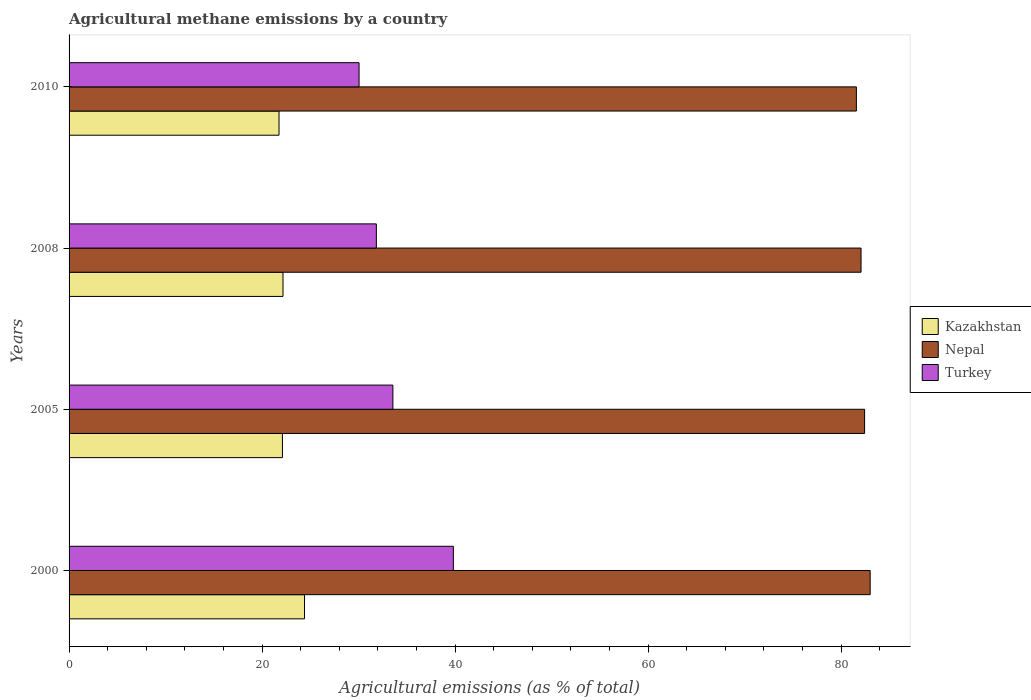How many different coloured bars are there?
Give a very brief answer. 3. How many groups of bars are there?
Provide a succinct answer. 4. Are the number of bars per tick equal to the number of legend labels?
Offer a very short reply. Yes. Are the number of bars on each tick of the Y-axis equal?
Keep it short and to the point. Yes. How many bars are there on the 1st tick from the top?
Keep it short and to the point. 3. How many bars are there on the 1st tick from the bottom?
Make the answer very short. 3. What is the label of the 2nd group of bars from the top?
Offer a very short reply. 2008. What is the amount of agricultural methane emitted in Turkey in 2010?
Provide a short and direct response. 30.05. Across all years, what is the maximum amount of agricultural methane emitted in Nepal?
Ensure brevity in your answer.  83.02. Across all years, what is the minimum amount of agricultural methane emitted in Turkey?
Your response must be concise. 30.05. In which year was the amount of agricultural methane emitted in Turkey maximum?
Ensure brevity in your answer.  2000. In which year was the amount of agricultural methane emitted in Turkey minimum?
Offer a terse response. 2010. What is the total amount of agricultural methane emitted in Turkey in the graph?
Keep it short and to the point. 135.29. What is the difference between the amount of agricultural methane emitted in Nepal in 2008 and that in 2010?
Give a very brief answer. 0.48. What is the difference between the amount of agricultural methane emitted in Turkey in 2005 and the amount of agricultural methane emitted in Kazakhstan in 2008?
Your answer should be compact. 11.39. What is the average amount of agricultural methane emitted in Turkey per year?
Offer a terse response. 33.82. In the year 2010, what is the difference between the amount of agricultural methane emitted in Turkey and amount of agricultural methane emitted in Nepal?
Provide a succinct answer. -51.54. What is the ratio of the amount of agricultural methane emitted in Kazakhstan in 2000 to that in 2010?
Provide a short and direct response. 1.12. Is the difference between the amount of agricultural methane emitted in Turkey in 2000 and 2005 greater than the difference between the amount of agricultural methane emitted in Nepal in 2000 and 2005?
Offer a terse response. Yes. What is the difference between the highest and the second highest amount of agricultural methane emitted in Nepal?
Your answer should be compact. 0.58. What is the difference between the highest and the lowest amount of agricultural methane emitted in Nepal?
Provide a short and direct response. 1.43. In how many years, is the amount of agricultural methane emitted in Nepal greater than the average amount of agricultural methane emitted in Nepal taken over all years?
Keep it short and to the point. 2. Is the sum of the amount of agricultural methane emitted in Nepal in 2000 and 2010 greater than the maximum amount of agricultural methane emitted in Turkey across all years?
Your answer should be compact. Yes. What does the 3rd bar from the top in 2005 represents?
Provide a succinct answer. Kazakhstan. How many bars are there?
Offer a very short reply. 12. Are all the bars in the graph horizontal?
Your answer should be very brief. Yes. How many years are there in the graph?
Your answer should be very brief. 4. Does the graph contain grids?
Provide a short and direct response. No. What is the title of the graph?
Your response must be concise. Agricultural methane emissions by a country. What is the label or title of the X-axis?
Your response must be concise. Agricultural emissions (as % of total). What is the label or title of the Y-axis?
Provide a succinct answer. Years. What is the Agricultural emissions (as % of total) in Kazakhstan in 2000?
Your answer should be compact. 24.4. What is the Agricultural emissions (as % of total) in Nepal in 2000?
Provide a short and direct response. 83.02. What is the Agricultural emissions (as % of total) of Turkey in 2000?
Make the answer very short. 39.83. What is the Agricultural emissions (as % of total) of Kazakhstan in 2005?
Provide a short and direct response. 22.11. What is the Agricultural emissions (as % of total) of Nepal in 2005?
Your response must be concise. 82.45. What is the Agricultural emissions (as % of total) of Turkey in 2005?
Provide a succinct answer. 33.56. What is the Agricultural emissions (as % of total) of Kazakhstan in 2008?
Make the answer very short. 22.17. What is the Agricultural emissions (as % of total) in Nepal in 2008?
Make the answer very short. 82.08. What is the Agricultural emissions (as % of total) in Turkey in 2008?
Give a very brief answer. 31.85. What is the Agricultural emissions (as % of total) in Kazakhstan in 2010?
Offer a very short reply. 21.76. What is the Agricultural emissions (as % of total) in Nepal in 2010?
Give a very brief answer. 81.6. What is the Agricultural emissions (as % of total) in Turkey in 2010?
Your answer should be compact. 30.05. Across all years, what is the maximum Agricultural emissions (as % of total) in Kazakhstan?
Keep it short and to the point. 24.4. Across all years, what is the maximum Agricultural emissions (as % of total) in Nepal?
Your answer should be very brief. 83.02. Across all years, what is the maximum Agricultural emissions (as % of total) of Turkey?
Your response must be concise. 39.83. Across all years, what is the minimum Agricultural emissions (as % of total) in Kazakhstan?
Offer a very short reply. 21.76. Across all years, what is the minimum Agricultural emissions (as % of total) of Nepal?
Ensure brevity in your answer.  81.6. Across all years, what is the minimum Agricultural emissions (as % of total) in Turkey?
Your response must be concise. 30.05. What is the total Agricultural emissions (as % of total) in Kazakhstan in the graph?
Give a very brief answer. 90.44. What is the total Agricultural emissions (as % of total) of Nepal in the graph?
Make the answer very short. 329.14. What is the total Agricultural emissions (as % of total) in Turkey in the graph?
Keep it short and to the point. 135.29. What is the difference between the Agricultural emissions (as % of total) in Kazakhstan in 2000 and that in 2005?
Your response must be concise. 2.29. What is the difference between the Agricultural emissions (as % of total) of Nepal in 2000 and that in 2005?
Your answer should be very brief. 0.58. What is the difference between the Agricultural emissions (as % of total) in Turkey in 2000 and that in 2005?
Offer a terse response. 6.27. What is the difference between the Agricultural emissions (as % of total) in Kazakhstan in 2000 and that in 2008?
Provide a short and direct response. 2.23. What is the difference between the Agricultural emissions (as % of total) of Nepal in 2000 and that in 2008?
Ensure brevity in your answer.  0.95. What is the difference between the Agricultural emissions (as % of total) in Turkey in 2000 and that in 2008?
Your answer should be very brief. 7.98. What is the difference between the Agricultural emissions (as % of total) of Kazakhstan in 2000 and that in 2010?
Your response must be concise. 2.64. What is the difference between the Agricultural emissions (as % of total) in Nepal in 2000 and that in 2010?
Ensure brevity in your answer.  1.43. What is the difference between the Agricultural emissions (as % of total) of Turkey in 2000 and that in 2010?
Provide a short and direct response. 9.77. What is the difference between the Agricultural emissions (as % of total) of Kazakhstan in 2005 and that in 2008?
Ensure brevity in your answer.  -0.06. What is the difference between the Agricultural emissions (as % of total) in Nepal in 2005 and that in 2008?
Offer a terse response. 0.37. What is the difference between the Agricultural emissions (as % of total) in Turkey in 2005 and that in 2008?
Offer a terse response. 1.71. What is the difference between the Agricultural emissions (as % of total) in Kazakhstan in 2005 and that in 2010?
Give a very brief answer. 0.36. What is the difference between the Agricultural emissions (as % of total) of Nepal in 2005 and that in 2010?
Offer a terse response. 0.85. What is the difference between the Agricultural emissions (as % of total) of Turkey in 2005 and that in 2010?
Offer a very short reply. 3.51. What is the difference between the Agricultural emissions (as % of total) of Kazakhstan in 2008 and that in 2010?
Your answer should be very brief. 0.41. What is the difference between the Agricultural emissions (as % of total) in Nepal in 2008 and that in 2010?
Provide a short and direct response. 0.48. What is the difference between the Agricultural emissions (as % of total) of Turkey in 2008 and that in 2010?
Keep it short and to the point. 1.79. What is the difference between the Agricultural emissions (as % of total) in Kazakhstan in 2000 and the Agricultural emissions (as % of total) in Nepal in 2005?
Offer a terse response. -58.04. What is the difference between the Agricultural emissions (as % of total) in Kazakhstan in 2000 and the Agricultural emissions (as % of total) in Turkey in 2005?
Your response must be concise. -9.16. What is the difference between the Agricultural emissions (as % of total) in Nepal in 2000 and the Agricultural emissions (as % of total) in Turkey in 2005?
Provide a short and direct response. 49.46. What is the difference between the Agricultural emissions (as % of total) in Kazakhstan in 2000 and the Agricultural emissions (as % of total) in Nepal in 2008?
Offer a terse response. -57.68. What is the difference between the Agricultural emissions (as % of total) in Kazakhstan in 2000 and the Agricultural emissions (as % of total) in Turkey in 2008?
Provide a short and direct response. -7.45. What is the difference between the Agricultural emissions (as % of total) in Nepal in 2000 and the Agricultural emissions (as % of total) in Turkey in 2008?
Provide a succinct answer. 51.18. What is the difference between the Agricultural emissions (as % of total) in Kazakhstan in 2000 and the Agricultural emissions (as % of total) in Nepal in 2010?
Make the answer very short. -57.19. What is the difference between the Agricultural emissions (as % of total) of Kazakhstan in 2000 and the Agricultural emissions (as % of total) of Turkey in 2010?
Keep it short and to the point. -5.65. What is the difference between the Agricultural emissions (as % of total) in Nepal in 2000 and the Agricultural emissions (as % of total) in Turkey in 2010?
Your answer should be compact. 52.97. What is the difference between the Agricultural emissions (as % of total) in Kazakhstan in 2005 and the Agricultural emissions (as % of total) in Nepal in 2008?
Your answer should be very brief. -59.97. What is the difference between the Agricultural emissions (as % of total) in Kazakhstan in 2005 and the Agricultural emissions (as % of total) in Turkey in 2008?
Make the answer very short. -9.73. What is the difference between the Agricultural emissions (as % of total) in Nepal in 2005 and the Agricultural emissions (as % of total) in Turkey in 2008?
Your response must be concise. 50.6. What is the difference between the Agricultural emissions (as % of total) of Kazakhstan in 2005 and the Agricultural emissions (as % of total) of Nepal in 2010?
Offer a terse response. -59.48. What is the difference between the Agricultural emissions (as % of total) in Kazakhstan in 2005 and the Agricultural emissions (as % of total) in Turkey in 2010?
Offer a very short reply. -7.94. What is the difference between the Agricultural emissions (as % of total) of Nepal in 2005 and the Agricultural emissions (as % of total) of Turkey in 2010?
Offer a very short reply. 52.39. What is the difference between the Agricultural emissions (as % of total) of Kazakhstan in 2008 and the Agricultural emissions (as % of total) of Nepal in 2010?
Your answer should be compact. -59.42. What is the difference between the Agricultural emissions (as % of total) in Kazakhstan in 2008 and the Agricultural emissions (as % of total) in Turkey in 2010?
Keep it short and to the point. -7.88. What is the difference between the Agricultural emissions (as % of total) of Nepal in 2008 and the Agricultural emissions (as % of total) of Turkey in 2010?
Give a very brief answer. 52.03. What is the average Agricultural emissions (as % of total) of Kazakhstan per year?
Your answer should be very brief. 22.61. What is the average Agricultural emissions (as % of total) in Nepal per year?
Your response must be concise. 82.29. What is the average Agricultural emissions (as % of total) of Turkey per year?
Your response must be concise. 33.82. In the year 2000, what is the difference between the Agricultural emissions (as % of total) in Kazakhstan and Agricultural emissions (as % of total) in Nepal?
Provide a succinct answer. -58.62. In the year 2000, what is the difference between the Agricultural emissions (as % of total) of Kazakhstan and Agricultural emissions (as % of total) of Turkey?
Your answer should be very brief. -15.43. In the year 2000, what is the difference between the Agricultural emissions (as % of total) in Nepal and Agricultural emissions (as % of total) in Turkey?
Your answer should be very brief. 43.2. In the year 2005, what is the difference between the Agricultural emissions (as % of total) in Kazakhstan and Agricultural emissions (as % of total) in Nepal?
Offer a very short reply. -60.33. In the year 2005, what is the difference between the Agricultural emissions (as % of total) in Kazakhstan and Agricultural emissions (as % of total) in Turkey?
Provide a succinct answer. -11.45. In the year 2005, what is the difference between the Agricultural emissions (as % of total) in Nepal and Agricultural emissions (as % of total) in Turkey?
Offer a terse response. 48.89. In the year 2008, what is the difference between the Agricultural emissions (as % of total) in Kazakhstan and Agricultural emissions (as % of total) in Nepal?
Your response must be concise. -59.91. In the year 2008, what is the difference between the Agricultural emissions (as % of total) of Kazakhstan and Agricultural emissions (as % of total) of Turkey?
Your answer should be very brief. -9.68. In the year 2008, what is the difference between the Agricultural emissions (as % of total) of Nepal and Agricultural emissions (as % of total) of Turkey?
Your response must be concise. 50.23. In the year 2010, what is the difference between the Agricultural emissions (as % of total) in Kazakhstan and Agricultural emissions (as % of total) in Nepal?
Make the answer very short. -59.84. In the year 2010, what is the difference between the Agricultural emissions (as % of total) of Kazakhstan and Agricultural emissions (as % of total) of Turkey?
Offer a very short reply. -8.3. In the year 2010, what is the difference between the Agricultural emissions (as % of total) of Nepal and Agricultural emissions (as % of total) of Turkey?
Ensure brevity in your answer.  51.54. What is the ratio of the Agricultural emissions (as % of total) in Kazakhstan in 2000 to that in 2005?
Keep it short and to the point. 1.1. What is the ratio of the Agricultural emissions (as % of total) of Turkey in 2000 to that in 2005?
Provide a succinct answer. 1.19. What is the ratio of the Agricultural emissions (as % of total) in Kazakhstan in 2000 to that in 2008?
Make the answer very short. 1.1. What is the ratio of the Agricultural emissions (as % of total) in Nepal in 2000 to that in 2008?
Keep it short and to the point. 1.01. What is the ratio of the Agricultural emissions (as % of total) in Turkey in 2000 to that in 2008?
Offer a very short reply. 1.25. What is the ratio of the Agricultural emissions (as % of total) of Kazakhstan in 2000 to that in 2010?
Keep it short and to the point. 1.12. What is the ratio of the Agricultural emissions (as % of total) of Nepal in 2000 to that in 2010?
Your answer should be very brief. 1.02. What is the ratio of the Agricultural emissions (as % of total) of Turkey in 2000 to that in 2010?
Your answer should be compact. 1.33. What is the ratio of the Agricultural emissions (as % of total) of Turkey in 2005 to that in 2008?
Provide a short and direct response. 1.05. What is the ratio of the Agricultural emissions (as % of total) in Kazakhstan in 2005 to that in 2010?
Keep it short and to the point. 1.02. What is the ratio of the Agricultural emissions (as % of total) of Nepal in 2005 to that in 2010?
Make the answer very short. 1.01. What is the ratio of the Agricultural emissions (as % of total) of Turkey in 2005 to that in 2010?
Provide a short and direct response. 1.12. What is the ratio of the Agricultural emissions (as % of total) in Nepal in 2008 to that in 2010?
Your answer should be very brief. 1.01. What is the ratio of the Agricultural emissions (as % of total) in Turkey in 2008 to that in 2010?
Keep it short and to the point. 1.06. What is the difference between the highest and the second highest Agricultural emissions (as % of total) in Kazakhstan?
Ensure brevity in your answer.  2.23. What is the difference between the highest and the second highest Agricultural emissions (as % of total) of Nepal?
Give a very brief answer. 0.58. What is the difference between the highest and the second highest Agricultural emissions (as % of total) of Turkey?
Your answer should be very brief. 6.27. What is the difference between the highest and the lowest Agricultural emissions (as % of total) of Kazakhstan?
Offer a very short reply. 2.64. What is the difference between the highest and the lowest Agricultural emissions (as % of total) in Nepal?
Make the answer very short. 1.43. What is the difference between the highest and the lowest Agricultural emissions (as % of total) in Turkey?
Your answer should be very brief. 9.77. 